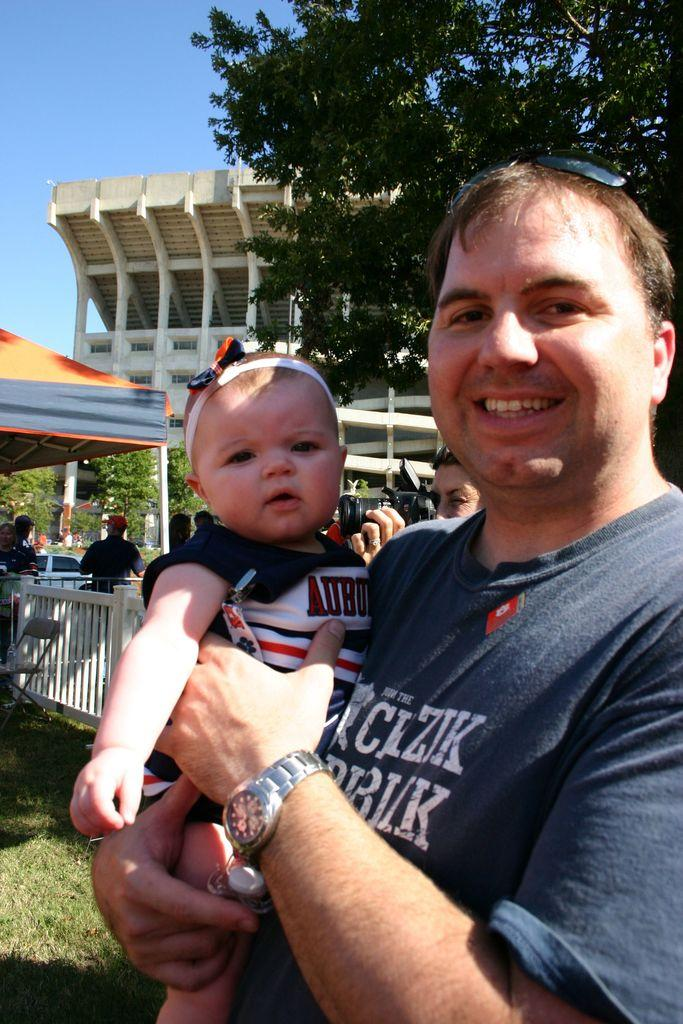What is the person in the image doing? The person is holding a kid in the image. What can be seen in the image besides the person and the kid? There is a tree in the image. What is visible in the background of the image? There are people and a building in the background of the image. What is visible at the top of the image? The sky is visible at the top of the image. What year is depicted in the image? The image does not depict a specific year; it is a photograph or illustration that captures a moment in time. Is there a volcano visible in the image? No, there is no volcano present in the image. 